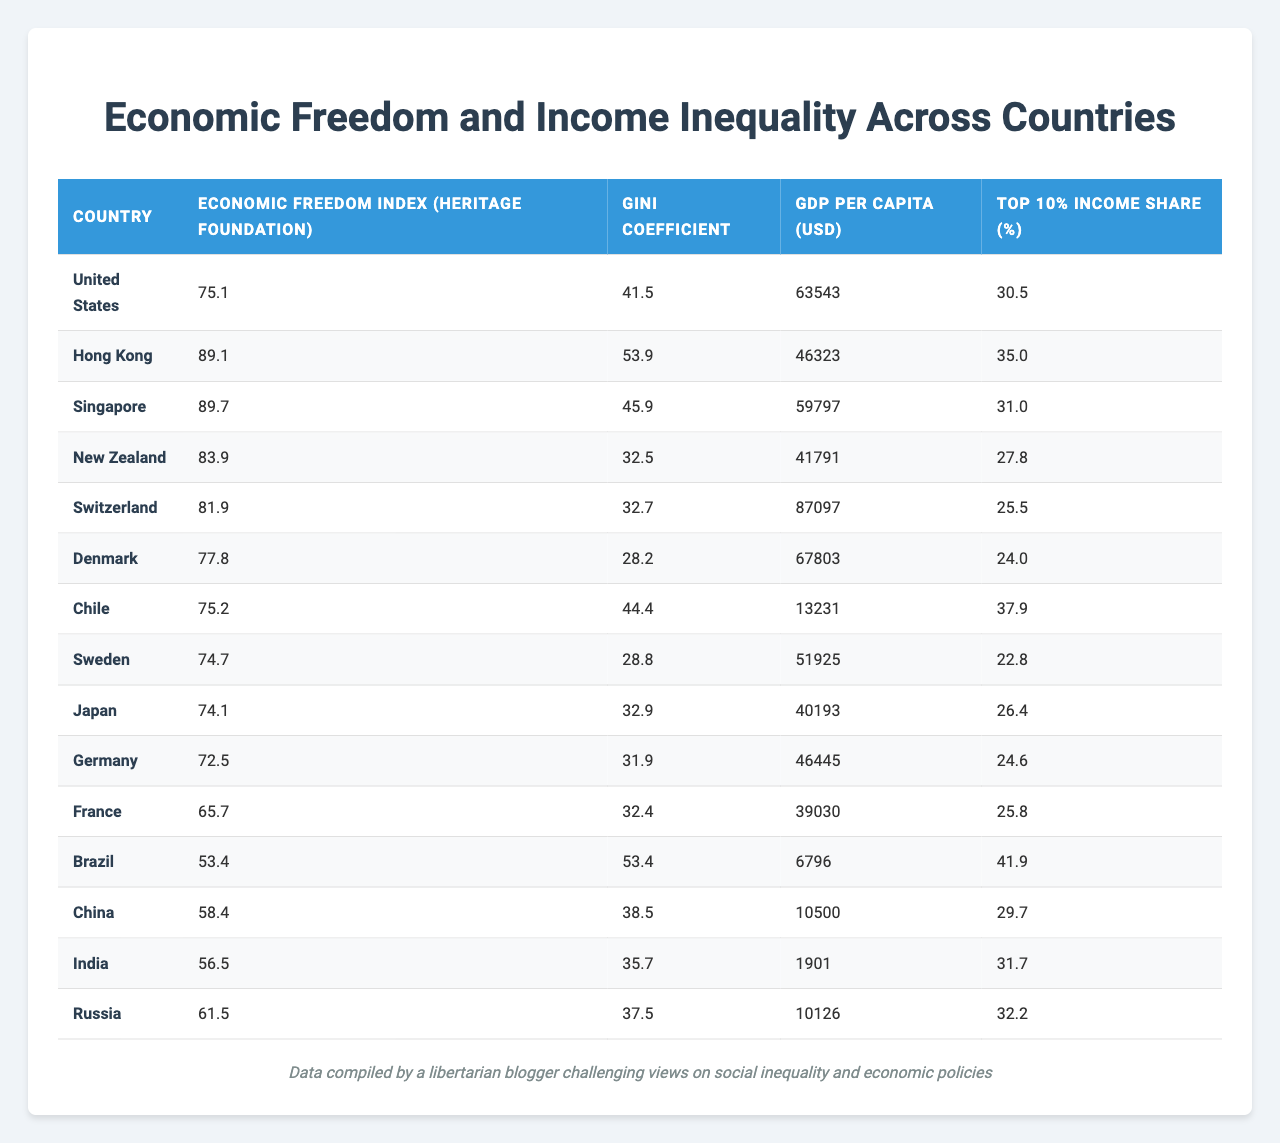What is the Gini coefficient for Sweden? The Gini coefficient for Sweden can be found in the table in the row corresponding to Sweden, which shows a value of 28.8.
Answer: 28.8 What is the economic freedom index of Brazil? The economic freedom index for Brazil can be located in the corresponding row for Brazil, which lists a value of 53.4.
Answer: 53.4 Which country has the highest GDP per capita? By comparing the GDP per capita values in the table, Switzerland has the highest GDP per capita listed at 87097 USD.
Answer: Switzerland What is the average Gini coefficient of the countries listed? To find the average, add all Gini coefficients: (41.5 + 53.9 + 45.9 + 32.5 + 32.7 + 28.2 + 44.4 + 28.8 + 32.9 + 31.9 + 32.4 + 53.4 + 38.5 + 35.7 + 37.5) = 609.9. Then divide by the number of countries, which is 15. The average is 609.9 / 15 = 40.66.
Answer: 40.66 Which country has both a high economic freedom index and low income inequality (as indicated by the Gini coefficient)? Analyze the table and find countries that have a high economic freedom index (above 80) and a Gini coefficient below 30. Denmark fits this criterion with an index of 77.8 and a Gini coefficient of 28.2.
Answer: Denmark Is there a correlation between the economic freedom index and top 10% income share among these countries? To analyze the correlation, compare both columns. While some countries with high economic freedom (e.g., Hong Kong and Singapore) have higher top 10% income shares, others like New Zealand and Denmark have lower shares. Thus, there isn't a clear and consistent correlation.
Answer: No clear correlation How does the Gini coefficient of the United States compare to that of Denmark? The Gini coefficient for the United States is 41.5 while for Denmark it is 28.2. To compare, United States has a higher Gini coefficient than Denmark, indicating greater income inequality in the United States.
Answer: Higher for the United States Which country with the lowest economic freedom index also has the highest Gini coefficient? From the table, Brazil has the lowest economic freedom index at 53.4 and it also matches the highest Gini coefficient at 53.4. Thus, Brazil is the country with the highest income inequality and lowest economic freedom index.
Answer: Brazil What is the difference in GDP per capita between Singapore and China? The GDP per capita for Singapore is 59797 USD and for China it is 10500 USD. Calculate the difference: 59797 - 10500 = 49297.
Answer: 49297 USD Which country shows a top 10% income share lower than the Gini coefficient? Looking at the table, Brazil has a top 10% income share of 41.9%, which is higher than its Gini coefficient of 53.4, thus it does not meet the criterion. However, New Zealand, with a top 10% share of 27.8% and a Gini coefficient of 32.5%, does fulfill the requirement.
Answer: New Zealand 